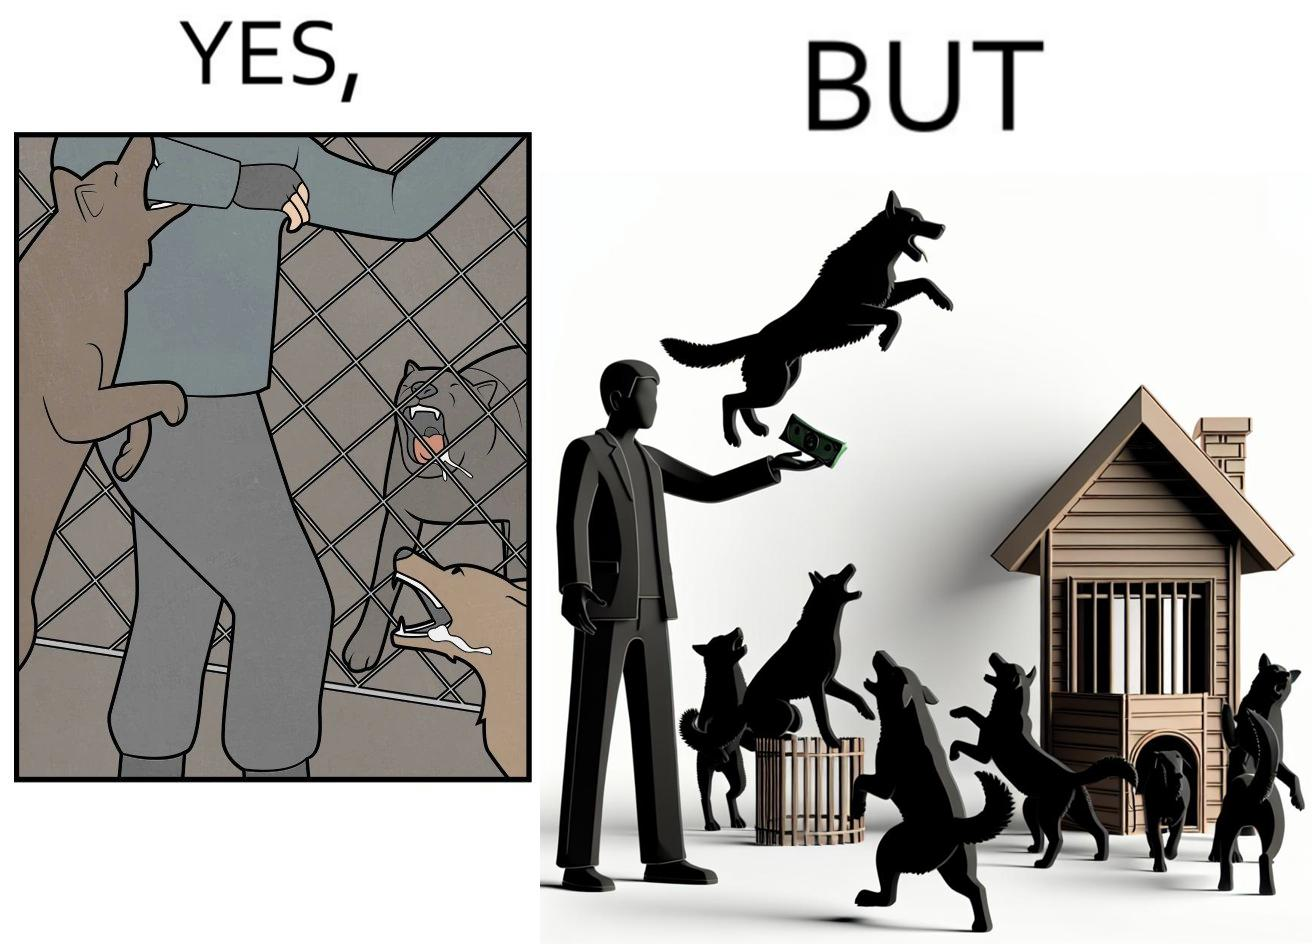Describe what you see in the left and right parts of this image. In the left part of the image: It is a man donating money to a dog shelter while dogs are barking at him In the right part of the image: It is a man donating money to a dog shelter while dogs are barking at him and one of the dogs is attacking him 